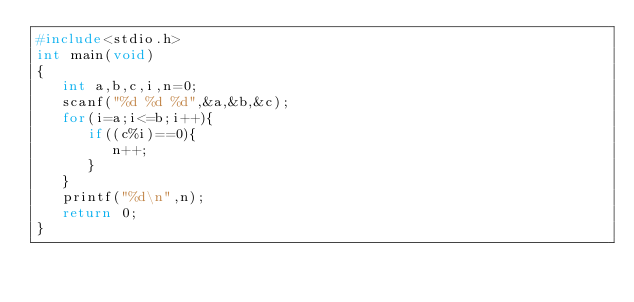Convert code to text. <code><loc_0><loc_0><loc_500><loc_500><_C_>#include<stdio.h>
int main(void)
{
   int a,b,c,i,n=0;
   scanf("%d %d %d",&a,&b,&c);
   for(i=a;i<=b;i++){
      if((c%i)==0){
         n++;
      }
   }
   printf("%d\n",n);
   return 0;
}</code> 